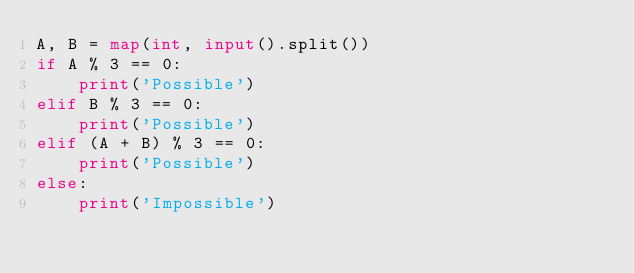<code> <loc_0><loc_0><loc_500><loc_500><_Python_>A, B = map(int, input().split())
if A % 3 == 0:
    print('Possible')
elif B % 3 == 0:
    print('Possible')
elif (A + B) % 3 == 0:
    print('Possible')
else:
    print('Impossible')
    </code> 